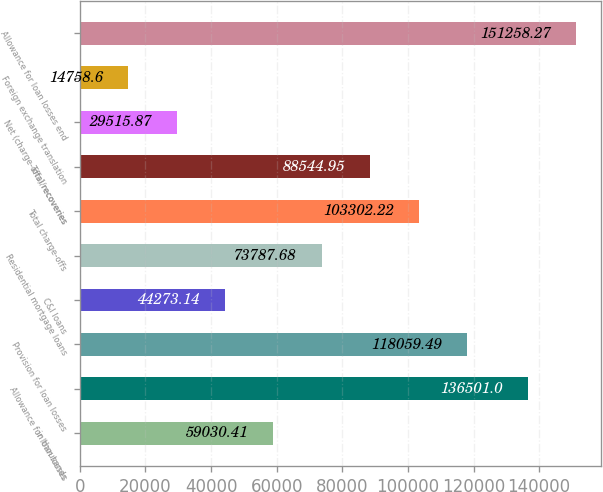Convert chart. <chart><loc_0><loc_0><loc_500><loc_500><bar_chart><fcel>in thousands<fcel>Allowance for loan losses<fcel>Provision for loan losses<fcel>C&I loans<fcel>Residential mortgage loans<fcel>Total charge-offs<fcel>Total recoveries<fcel>Net (charge-offs)/recoveries<fcel>Foreign exchange translation<fcel>Allowance for loan losses end<nl><fcel>59030.4<fcel>136501<fcel>118059<fcel>44273.1<fcel>73787.7<fcel>103302<fcel>88544.9<fcel>29515.9<fcel>14758.6<fcel>151258<nl></chart> 